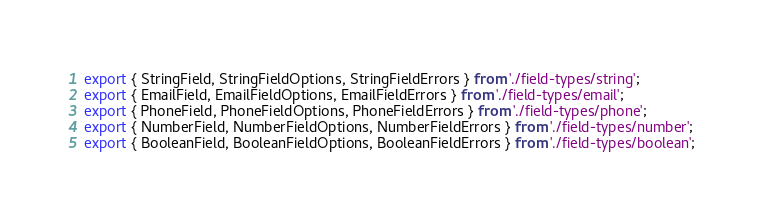<code> <loc_0><loc_0><loc_500><loc_500><_TypeScript_>export { StringField, StringFieldOptions, StringFieldErrors } from './field-types/string';
export { EmailField, EmailFieldOptions, EmailFieldErrors } from './field-types/email';
export { PhoneField, PhoneFieldOptions, PhoneFieldErrors } from './field-types/phone';
export { NumberField, NumberFieldOptions, NumberFieldErrors } from './field-types/number';
export { BooleanField, BooleanFieldOptions, BooleanFieldErrors } from './field-types/boolean';
</code> 